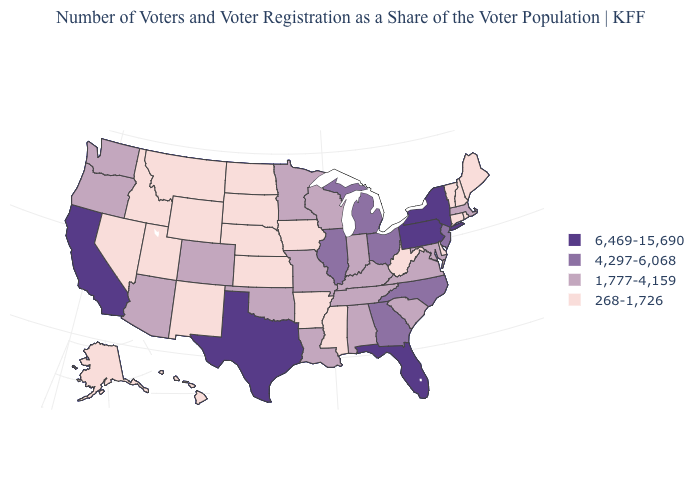What is the lowest value in states that border Connecticut?
Write a very short answer. 268-1,726. Name the states that have a value in the range 1,777-4,159?
Quick response, please. Alabama, Arizona, Colorado, Indiana, Kentucky, Louisiana, Maryland, Massachusetts, Minnesota, Missouri, Oklahoma, Oregon, South Carolina, Tennessee, Virginia, Washington, Wisconsin. Among the states that border California , which have the highest value?
Answer briefly. Arizona, Oregon. Does Mississippi have the lowest value in the South?
Write a very short answer. Yes. What is the value of West Virginia?
Write a very short answer. 268-1,726. What is the value of Maryland?
Short answer required. 1,777-4,159. Does the first symbol in the legend represent the smallest category?
Concise answer only. No. Does Massachusetts have the lowest value in the Northeast?
Short answer required. No. Name the states that have a value in the range 6,469-15,690?
Write a very short answer. California, Florida, New York, Pennsylvania, Texas. What is the value of Mississippi?
Short answer required. 268-1,726. Among the states that border Massachusetts , does New York have the lowest value?
Short answer required. No. Which states have the lowest value in the USA?
Quick response, please. Alaska, Arkansas, Connecticut, Delaware, Hawaii, Idaho, Iowa, Kansas, Maine, Mississippi, Montana, Nebraska, Nevada, New Hampshire, New Mexico, North Dakota, Rhode Island, South Dakota, Utah, Vermont, West Virginia, Wyoming. What is the value of West Virginia?
Keep it brief. 268-1,726. Does South Carolina have a lower value than Washington?
Write a very short answer. No. Name the states that have a value in the range 6,469-15,690?
Write a very short answer. California, Florida, New York, Pennsylvania, Texas. 